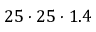<formula> <loc_0><loc_0><loc_500><loc_500>2 5 \cdot 2 5 \cdot 1 . 4</formula> 